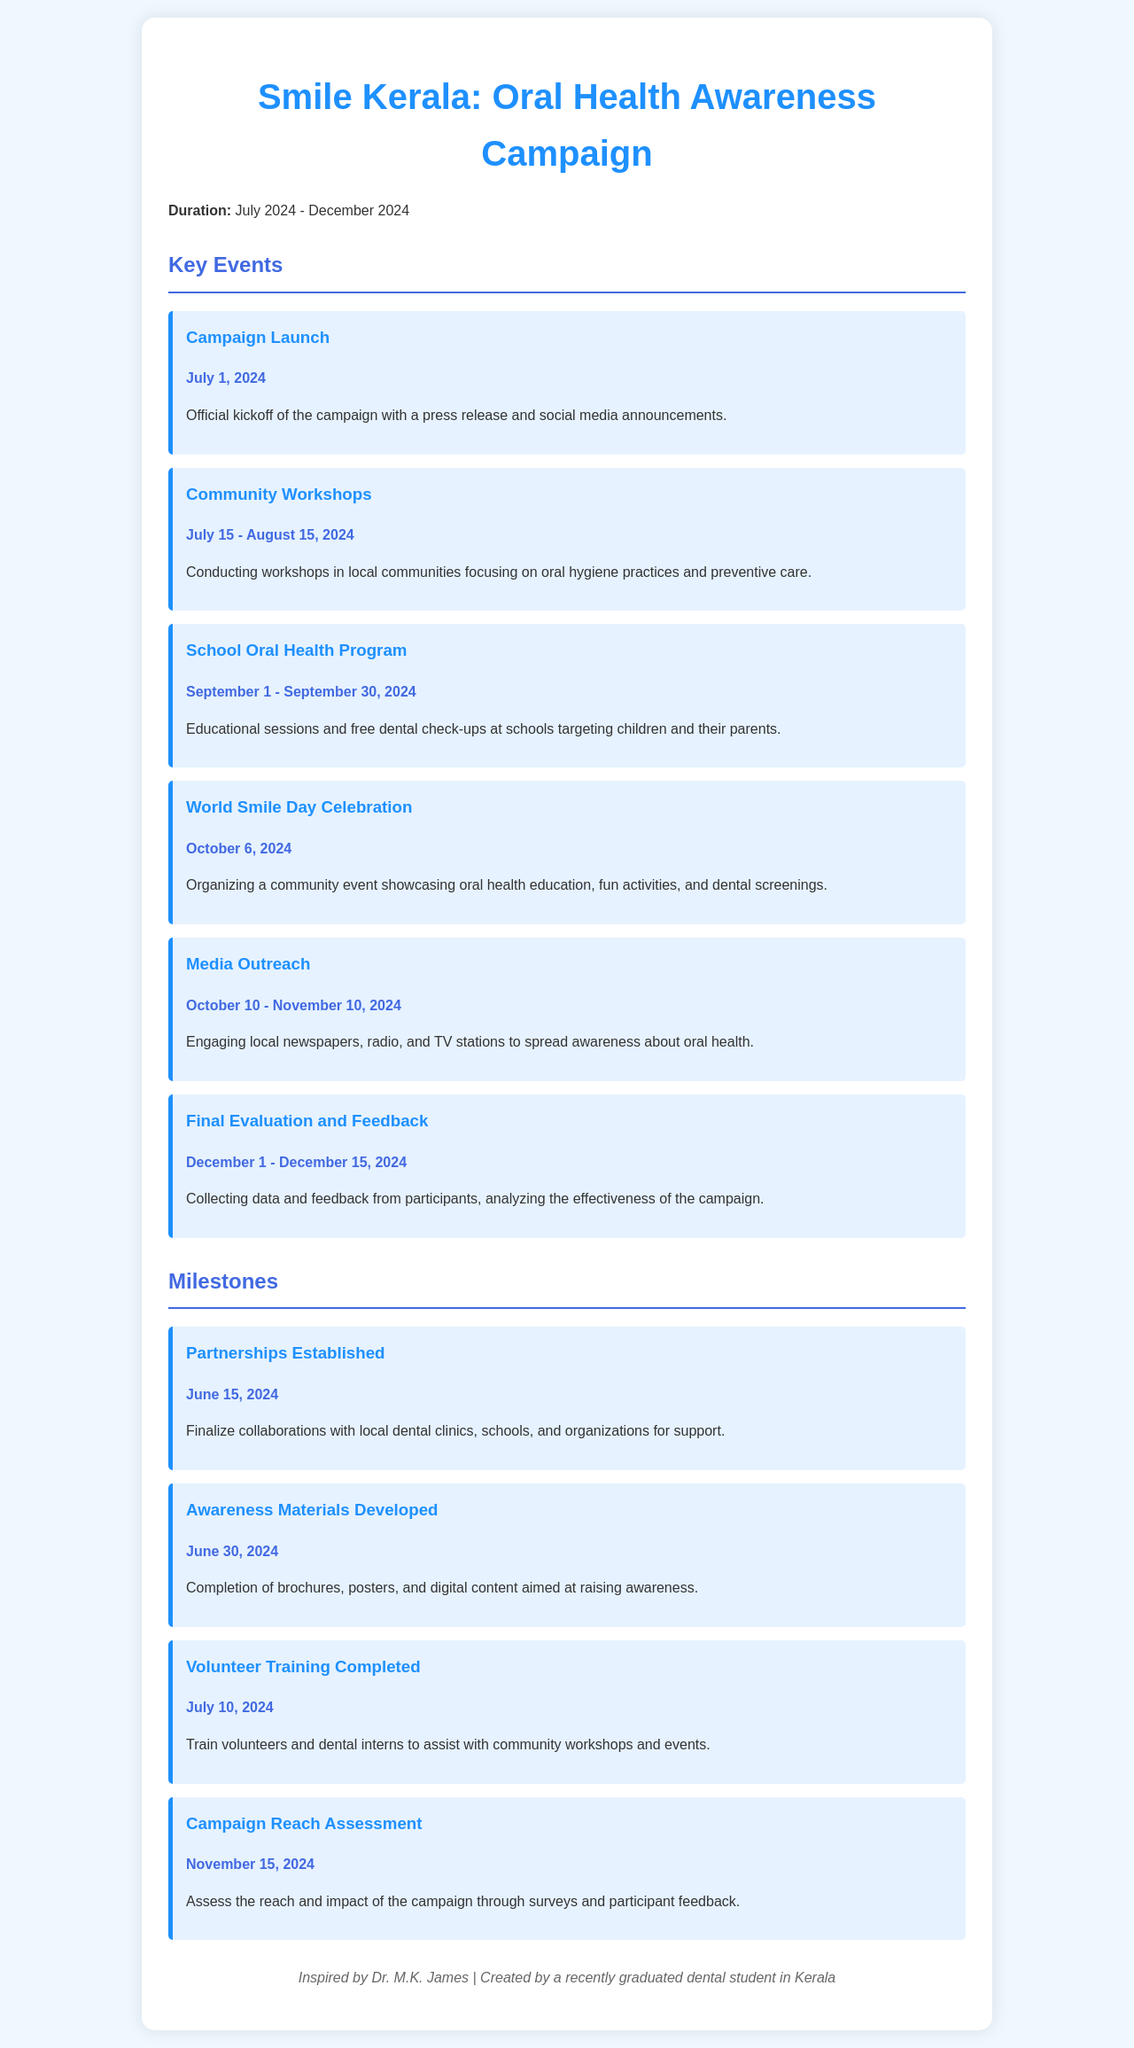what is the duration of the campaign? The duration of the campaign is specified in the document as July 2024 to December 2024.
Answer: July 2024 - December 2024 when is the campaign launch date? The document states the campaign launch date as July 1, 2024.
Answer: July 1, 2024 what event takes place between September 1 and September 30, 2024? The document lists the "School Oral Health Program" as the event occurring during this period.
Answer: School Oral Health Program how long do the community workshops last? The duration for the community workshops is detailed in the document as one month.
Answer: July 15 - August 15, 2024 what is the last milestone listed in the document? The last milestone mentioned is "Campaign Reach Assessment," which occurs on November 15, 2024.
Answer: Campaign Reach Assessment how many key events are there in the schedule? The document outlines a total of six key events in the campaign.
Answer: Six what is the focus of the community workshops? The description in the document specifies that the workshops focus on oral hygiene practices and preventive care.
Answer: Oral hygiene practices and preventive care when are the awareness materials developed? According to the document, the awareness materials are to be developed by June 30, 2024.
Answer: June 30, 2024 what type of event is organized on October 6, 2024? The document classifies this event as a community event celebrating World Smile Day.
Answer: Community event 